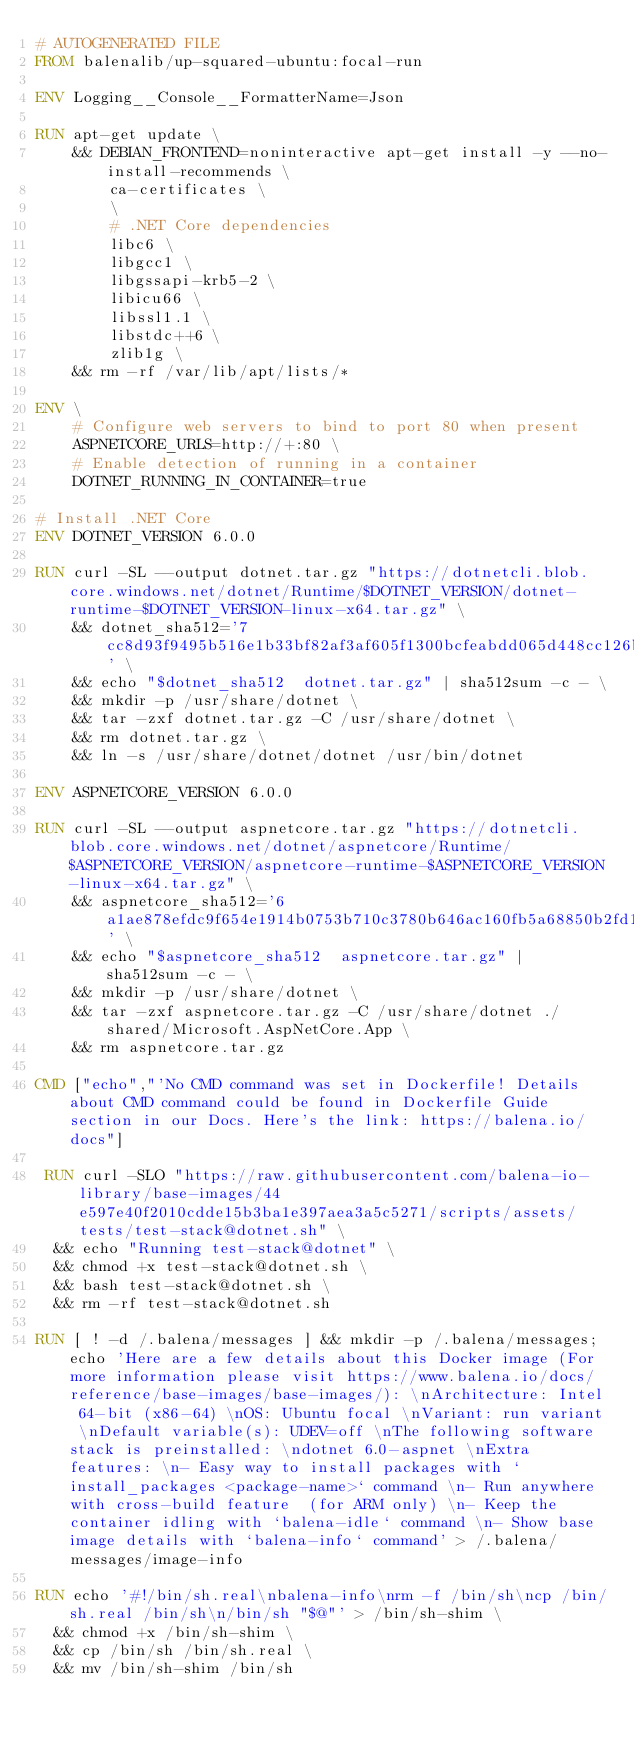<code> <loc_0><loc_0><loc_500><loc_500><_Dockerfile_># AUTOGENERATED FILE
FROM balenalib/up-squared-ubuntu:focal-run

ENV Logging__Console__FormatterName=Json

RUN apt-get update \
    && DEBIAN_FRONTEND=noninteractive apt-get install -y --no-install-recommends \
        ca-certificates \
        \
        # .NET Core dependencies
        libc6 \
        libgcc1 \
        libgssapi-krb5-2 \
        libicu66 \
        libssl1.1 \
        libstdc++6 \
        zlib1g \
    && rm -rf /var/lib/apt/lists/*

ENV \
    # Configure web servers to bind to port 80 when present
    ASPNETCORE_URLS=http://+:80 \
    # Enable detection of running in a container
    DOTNET_RUNNING_IN_CONTAINER=true

# Install .NET Core
ENV DOTNET_VERSION 6.0.0

RUN curl -SL --output dotnet.tar.gz "https://dotnetcli.blob.core.windows.net/dotnet/Runtime/$DOTNET_VERSION/dotnet-runtime-$DOTNET_VERSION-linux-x64.tar.gz" \
    && dotnet_sha512='7cc8d93f9495b516e1b33bf82af3af605f1300bcfeabdd065d448cc126bd97ab4da5ec5e95b7775ee70ab4baf899ff43671f5c6f647523fb41cda3d96f334ae5' \
    && echo "$dotnet_sha512  dotnet.tar.gz" | sha512sum -c - \
    && mkdir -p /usr/share/dotnet \
    && tar -zxf dotnet.tar.gz -C /usr/share/dotnet \
    && rm dotnet.tar.gz \
    && ln -s /usr/share/dotnet/dotnet /usr/bin/dotnet

ENV ASPNETCORE_VERSION 6.0.0

RUN curl -SL --output aspnetcore.tar.gz "https://dotnetcli.blob.core.windows.net/dotnet/aspnetcore/Runtime/$ASPNETCORE_VERSION/aspnetcore-runtime-$ASPNETCORE_VERSION-linux-x64.tar.gz" \
    && aspnetcore_sha512='6a1ae878efdc9f654e1914b0753b710c3780b646ac160fb5a68850b2fd1101675dc71e015dbbea6b4fcf1edac0822d3f7d470e9ed533dd81d0cfbcbbb1745c6c' \
    && echo "$aspnetcore_sha512  aspnetcore.tar.gz" | sha512sum -c - \
    && mkdir -p /usr/share/dotnet \
    && tar -zxf aspnetcore.tar.gz -C /usr/share/dotnet ./shared/Microsoft.AspNetCore.App \
    && rm aspnetcore.tar.gz

CMD ["echo","'No CMD command was set in Dockerfile! Details about CMD command could be found in Dockerfile Guide section in our Docs. Here's the link: https://balena.io/docs"]

 RUN curl -SLO "https://raw.githubusercontent.com/balena-io-library/base-images/44e597e40f2010cdde15b3ba1e397aea3a5c5271/scripts/assets/tests/test-stack@dotnet.sh" \
  && echo "Running test-stack@dotnet" \
  && chmod +x test-stack@dotnet.sh \
  && bash test-stack@dotnet.sh \
  && rm -rf test-stack@dotnet.sh 

RUN [ ! -d /.balena/messages ] && mkdir -p /.balena/messages; echo 'Here are a few details about this Docker image (For more information please visit https://www.balena.io/docs/reference/base-images/base-images/): \nArchitecture: Intel 64-bit (x86-64) \nOS: Ubuntu focal \nVariant: run variant \nDefault variable(s): UDEV=off \nThe following software stack is preinstalled: \ndotnet 6.0-aspnet \nExtra features: \n- Easy way to install packages with `install_packages <package-name>` command \n- Run anywhere with cross-build feature  (for ARM only) \n- Keep the container idling with `balena-idle` command \n- Show base image details with `balena-info` command' > /.balena/messages/image-info

RUN echo '#!/bin/sh.real\nbalena-info\nrm -f /bin/sh\ncp /bin/sh.real /bin/sh\n/bin/sh "$@"' > /bin/sh-shim \
	&& chmod +x /bin/sh-shim \
	&& cp /bin/sh /bin/sh.real \
	&& mv /bin/sh-shim /bin/sh</code> 